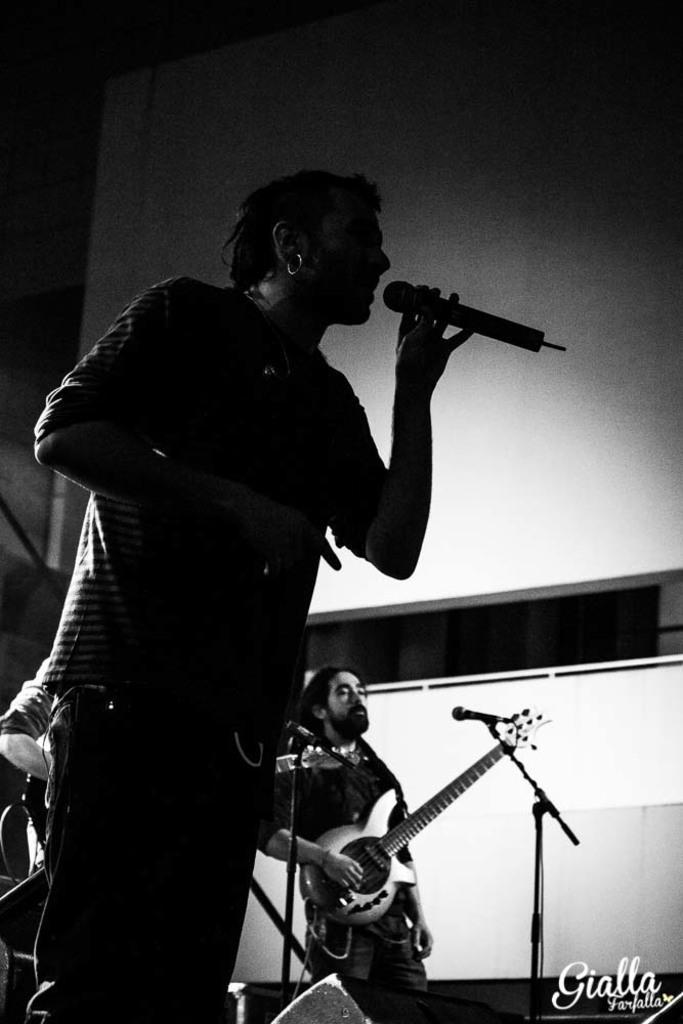Please provide a concise description of this image. here we can see that a person is standing and holding a microphone in his hand and he is singing, and at back a person is standing and playing a guitar, and here is the wall. 